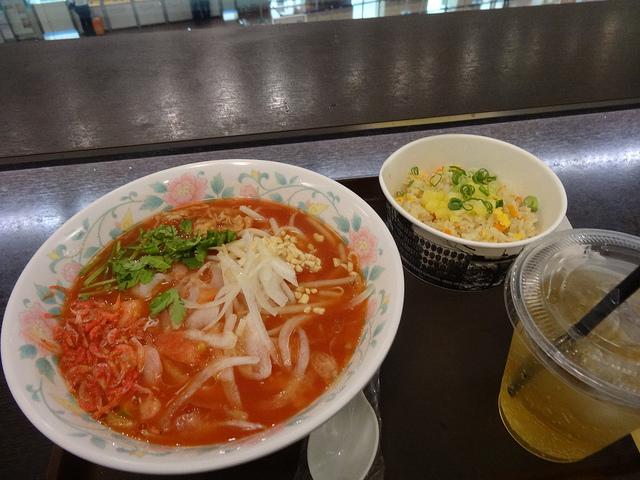Is this a tomato broth?
Be succinct. Yes. What restaurant is this?
Answer briefly. Chinese. Are there chips on the table?
Be succinct. No. What pattern is on the bowl?
Concise answer only. Floral. Which eating utensil would you use to eat this meal?
Quick response, please. Spoon. Is this inside someone's home?
Short answer required. No. 